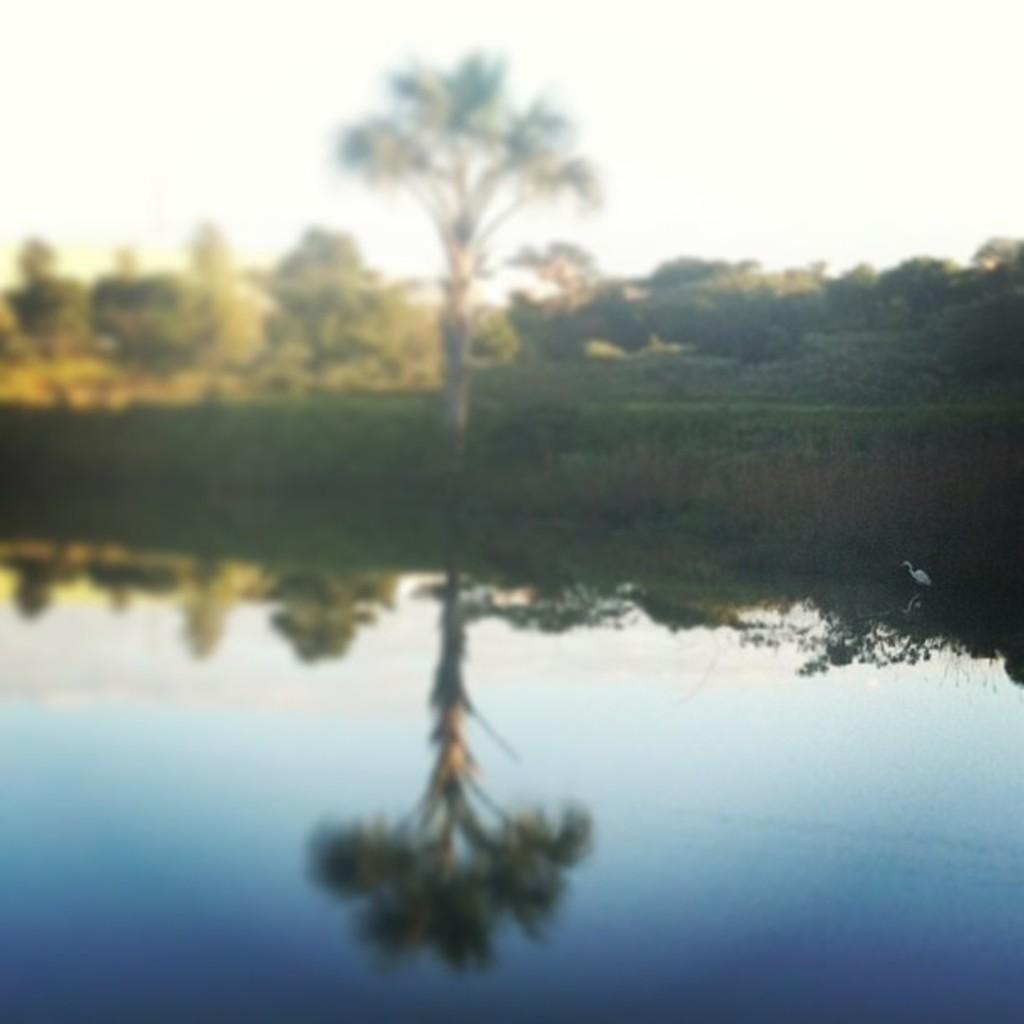Where was the image taken? The image was clicked outside. What can be seen in the middle of the image? There are trees in the middle of the image. What is visible at the bottom of the image? There is water at the bottom of the image. What is visible at the top of the image? There is sky at the top of the image. What is located on the right side of the image? There is a crane on the right side of the image. What type of liquid is being served to the parent in the image? There is no parent or liquid being served in the image. 